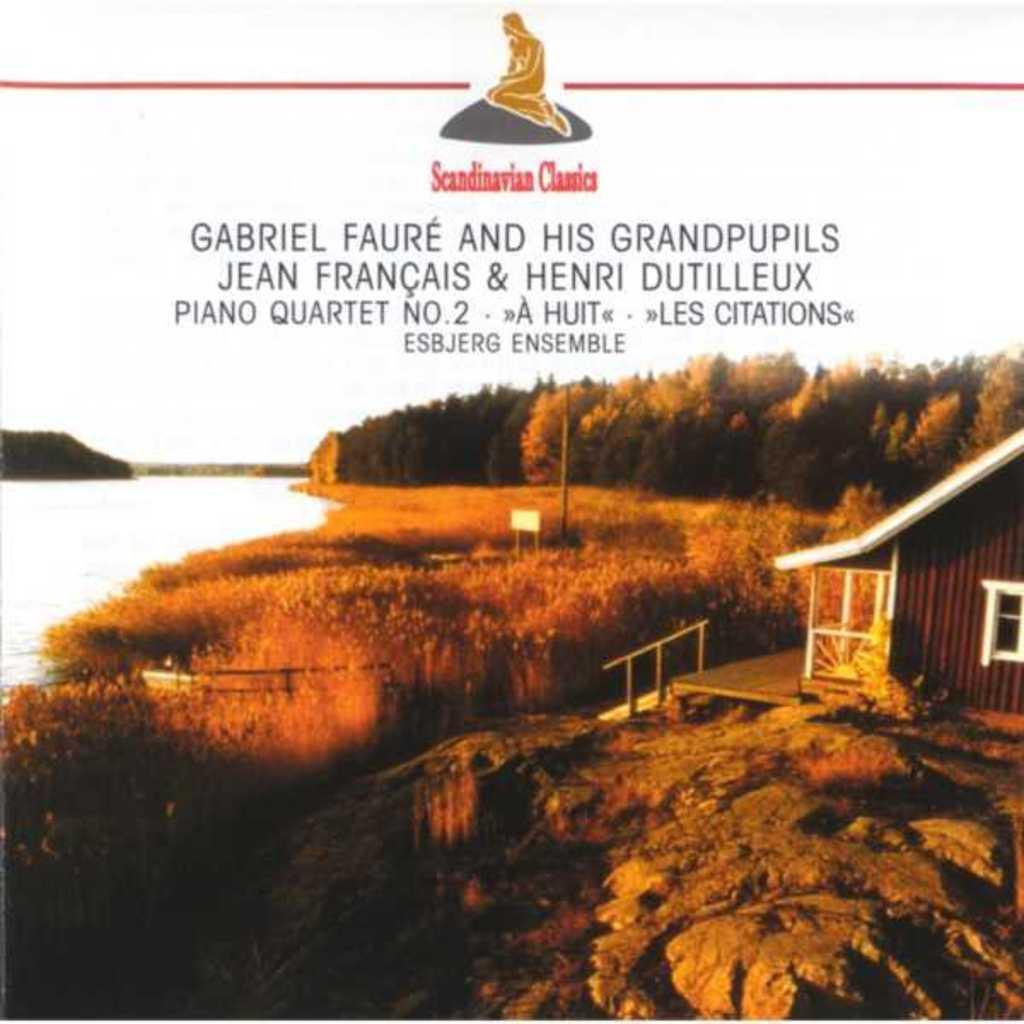How would you summarize this image in a sentence or two? At the bottom of the picture, we see rocks. Beside that, we see a hut in brown color with a white color roof. Beside that, we see a staircase and a stair railing. Beside that, we see grass and trees. On the left side, we see water and this water might be in the lake. There are trees in the background. At the top of the picture, we see some text written. This picture might be a poster. 